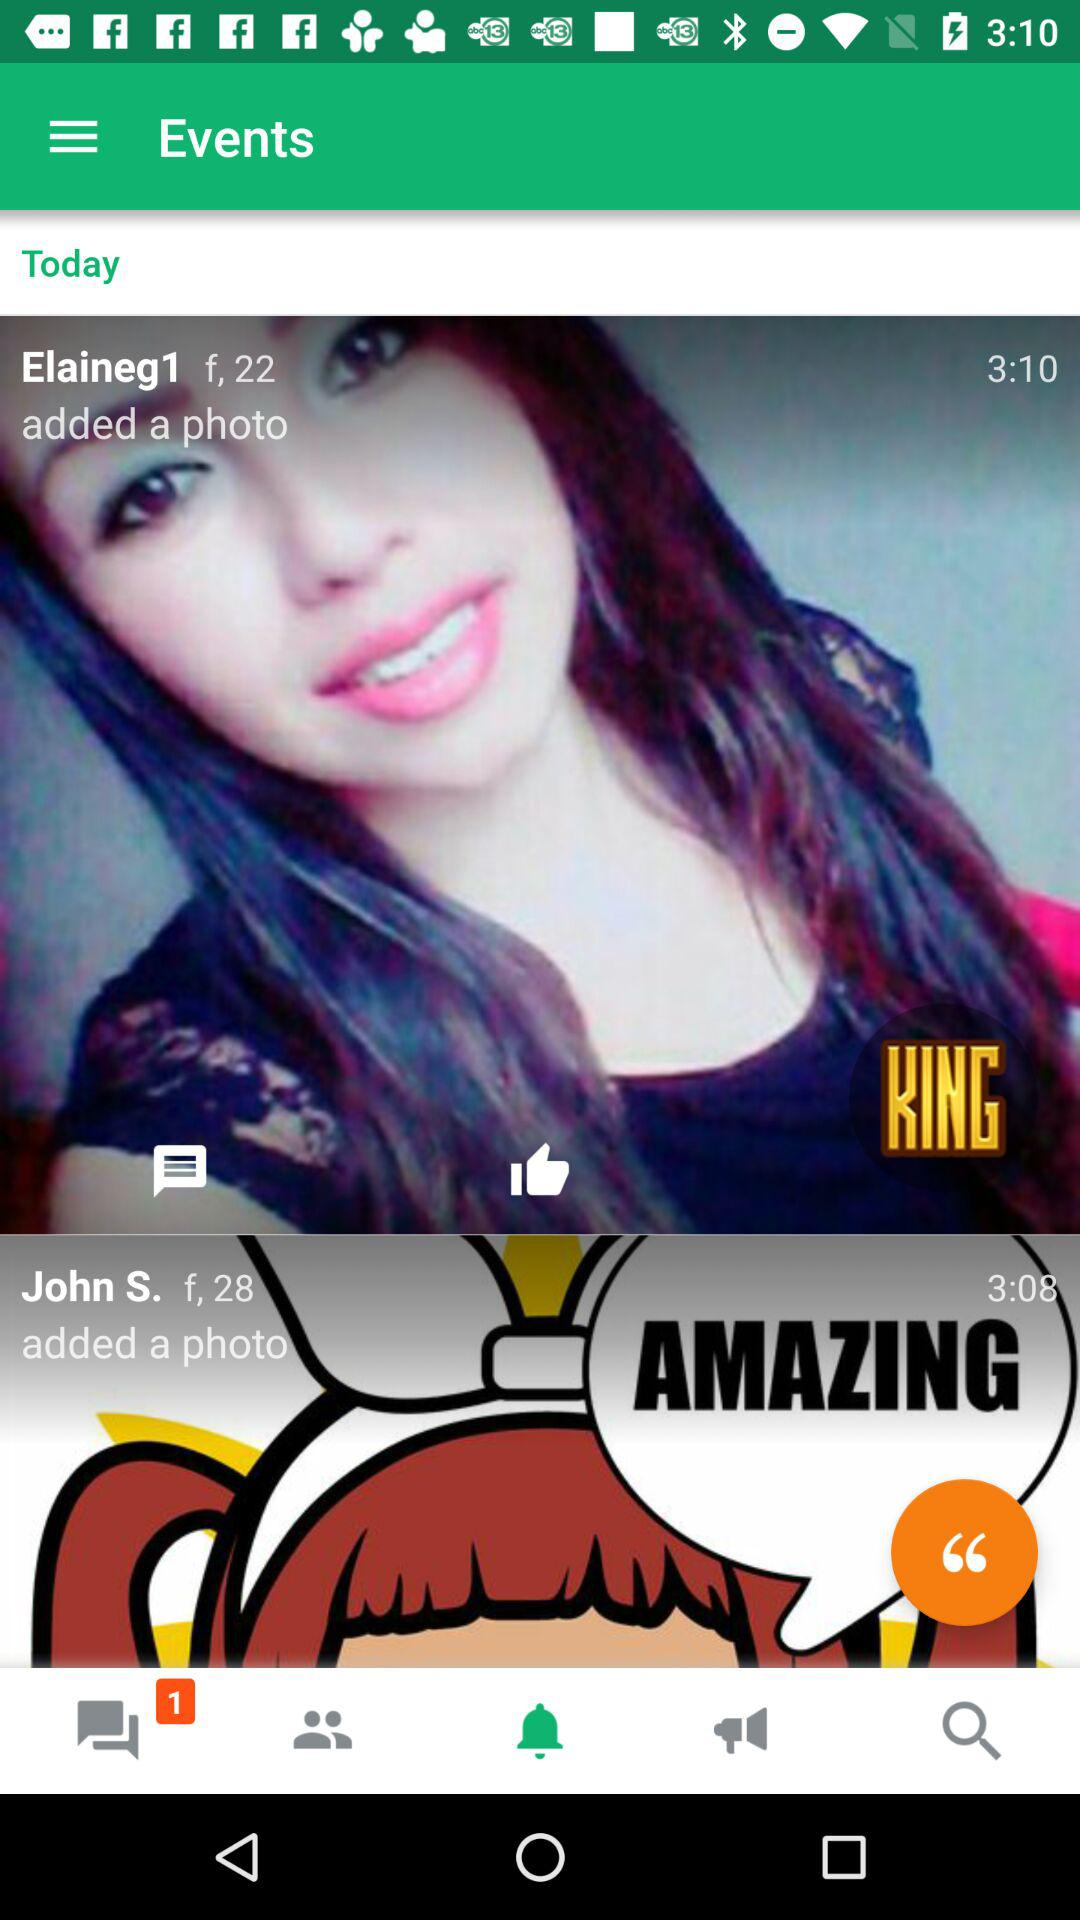What is the gender of John S.? The gender of John S. is female. 